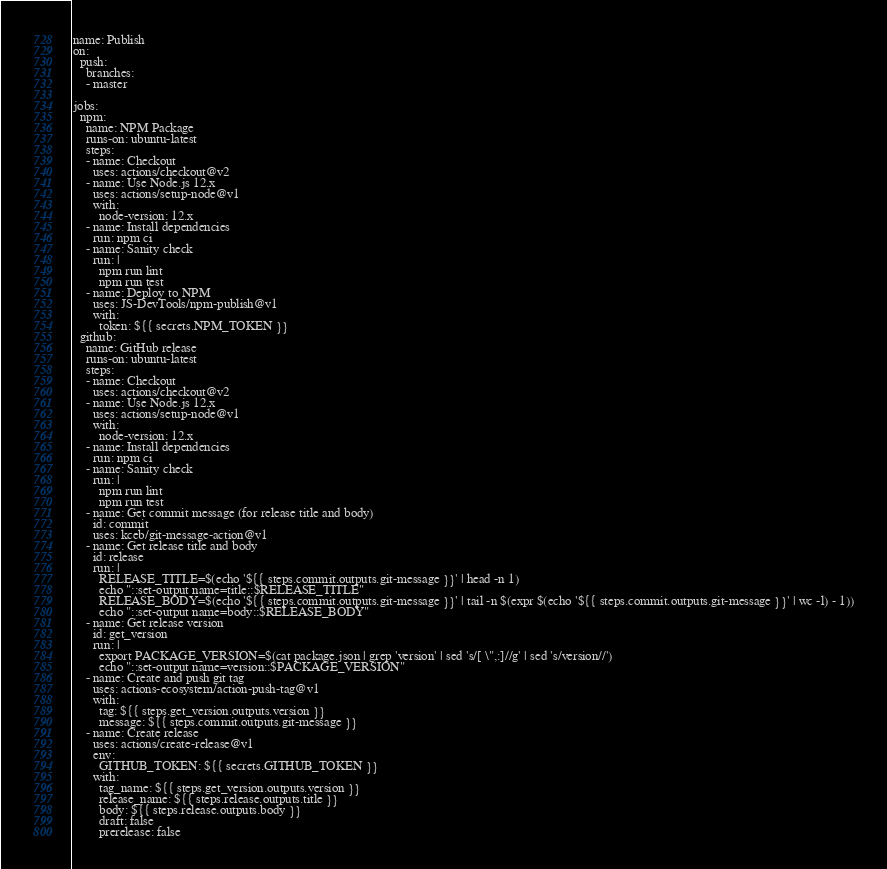Convert code to text. <code><loc_0><loc_0><loc_500><loc_500><_YAML_>name: Publish
on:
  push:
    branches:
    - master

jobs:
  npm:
    name: NPM Package
    runs-on: ubuntu-latest
    steps:
    - name: Checkout
      uses: actions/checkout@v2
    - name: Use Node.js 12.x
      uses: actions/setup-node@v1
      with:
        node-version: 12.x
    - name: Install dependencies
      run: npm ci
    - name: Sanity check
      run: |
        npm run lint
        npm run test
    - name: Deploy to NPM
      uses: JS-DevTools/npm-publish@v1
      with:
        token: ${{ secrets.NPM_TOKEN }}
  github:
    name: GitHub release
    runs-on: ubuntu-latest
    steps:
    - name: Checkout
      uses: actions/checkout@v2
    - name: Use Node.js 12.x
      uses: actions/setup-node@v1
      with:
        node-version: 12.x
    - name: Install dependencies
      run: npm ci
    - name: Sanity check
      run: |
        npm run lint
        npm run test
    - name: Get commit message (for release title and body)
      id: commit
      uses: kceb/git-message-action@v1
    - name: Get release title and body
      id: release
      run: |
        RELEASE_TITLE=$(echo '${{ steps.commit.outputs.git-message }}' | head -n 1)
        echo "::set-output name=title::$RELEASE_TITLE"
        RELEASE_BODY=$(echo '${{ steps.commit.outputs.git-message }}' | tail -n $(expr $(echo '${{ steps.commit.outputs.git-message }}' | wc -l) - 1))
        echo "::set-output name=body::$RELEASE_BODY"
    - name: Get release version
      id: get_version
      run: |
        export PACKAGE_VERSION=$(cat package.json | grep 'version' | sed 's/[ \",:]//g' | sed 's/version//')
        echo "::set-output name=version::$PACKAGE_VERSION"
    - name: Create and push git tag
      uses: actions-ecosystem/action-push-tag@v1
      with:
        tag: ${{ steps.get_version.outputs.version }}
        message: ${{ steps.commit.outputs.git-message }}
    - name: Create release
      uses: actions/create-release@v1
      env:
        GITHUB_TOKEN: ${{ secrets.GITHUB_TOKEN }}
      with:
        tag_name: ${{ steps.get_version.outputs.version }}
        release_name: ${{ steps.release.outputs.title }}
        body: ${{ steps.release.outputs.body }}
        draft: false
        prerelease: false
</code> 